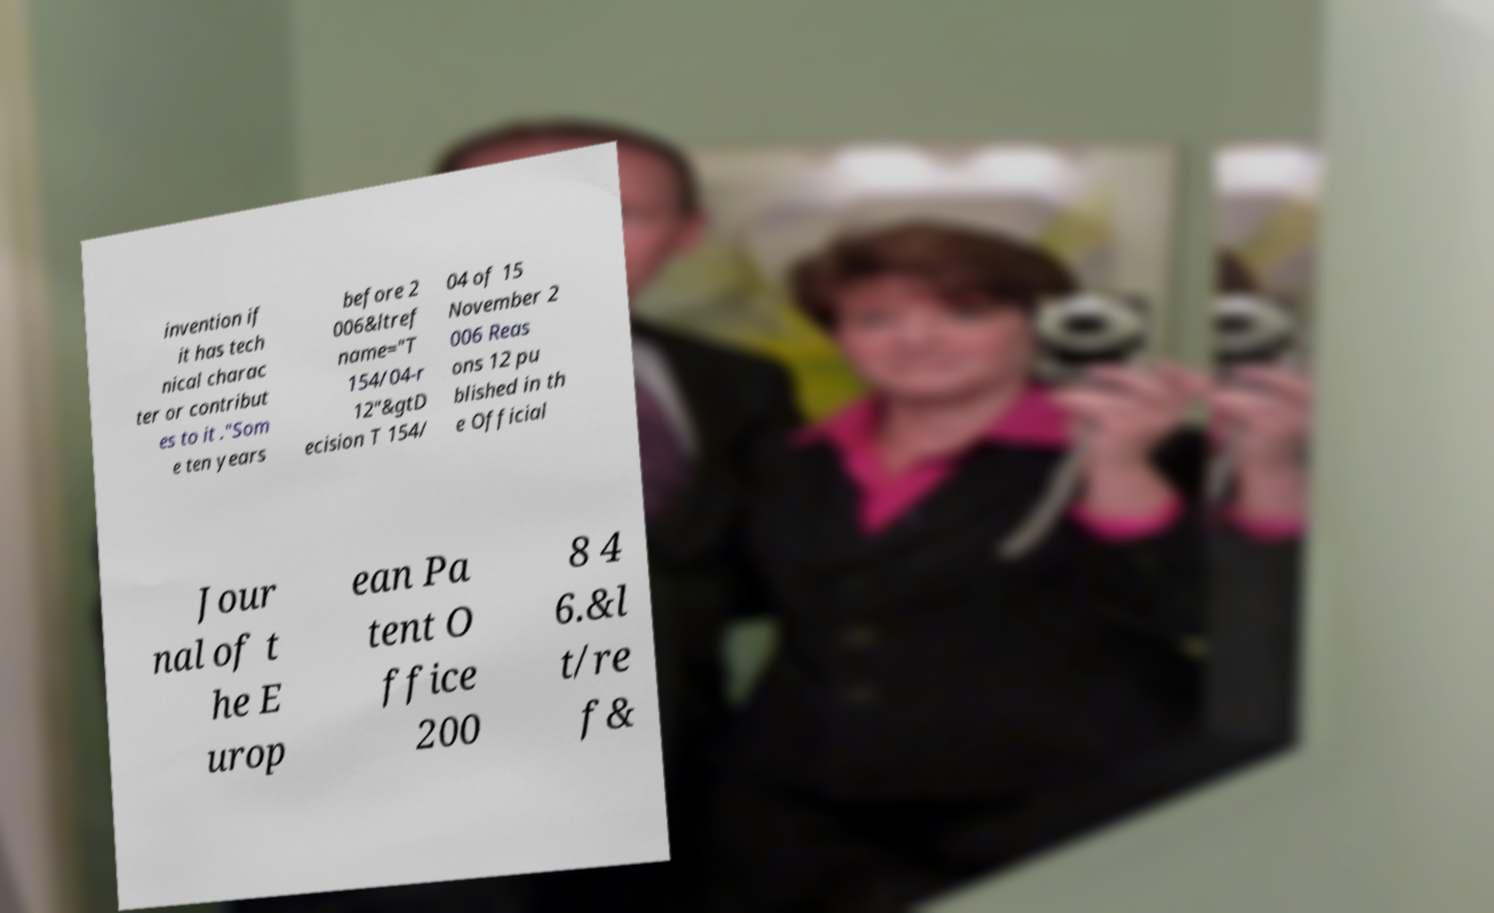Could you assist in decoding the text presented in this image and type it out clearly? invention if it has tech nical charac ter or contribut es to it ."Som e ten years before 2 006&ltref name="T 154/04-r 12"&gtD ecision T 154/ 04 of 15 November 2 006 Reas ons 12 pu blished in th e Official Jour nal of t he E urop ean Pa tent O ffice 200 8 4 6.&l t/re f& 